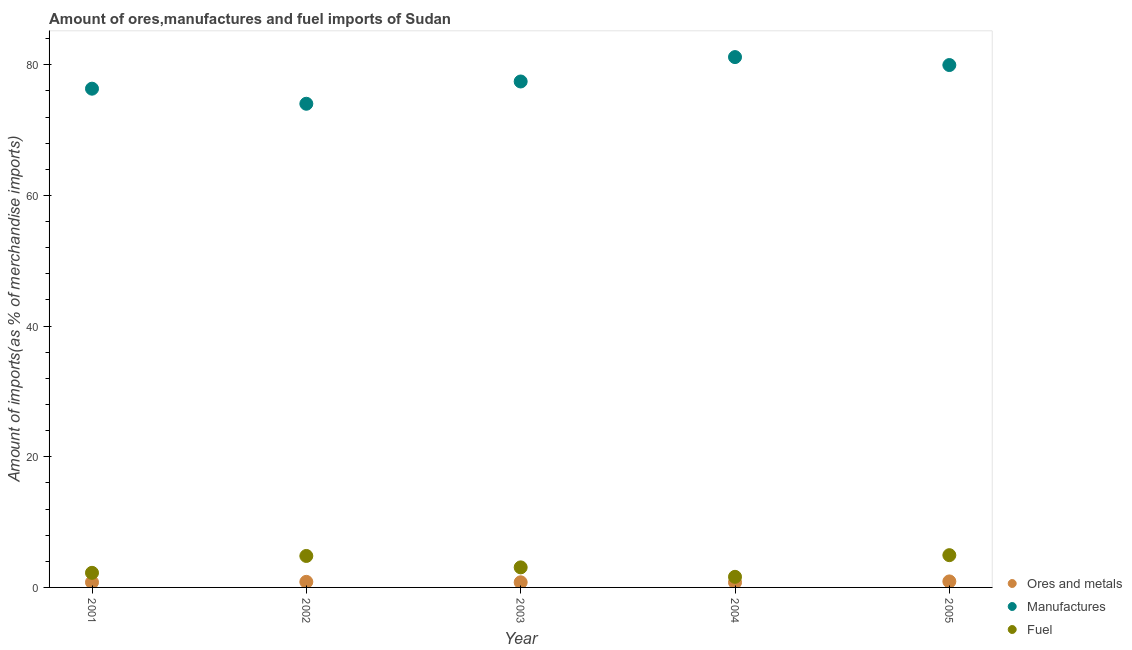What is the percentage of fuel imports in 2003?
Ensure brevity in your answer.  3.07. Across all years, what is the maximum percentage of ores and metals imports?
Offer a very short reply. 0.92. Across all years, what is the minimum percentage of fuel imports?
Your answer should be very brief. 1.62. In which year was the percentage of manufactures imports maximum?
Provide a short and direct response. 2004. In which year was the percentage of fuel imports minimum?
Your answer should be compact. 2004. What is the total percentage of manufactures imports in the graph?
Make the answer very short. 388.96. What is the difference between the percentage of fuel imports in 2002 and that in 2003?
Keep it short and to the point. 1.75. What is the difference between the percentage of fuel imports in 2002 and the percentage of ores and metals imports in 2005?
Offer a very short reply. 3.9. What is the average percentage of manufactures imports per year?
Provide a succinct answer. 77.79. In the year 2002, what is the difference between the percentage of fuel imports and percentage of ores and metals imports?
Provide a succinct answer. 3.96. In how many years, is the percentage of fuel imports greater than 76 %?
Your answer should be very brief. 0. What is the ratio of the percentage of manufactures imports in 2002 to that in 2005?
Offer a very short reply. 0.93. Is the difference between the percentage of fuel imports in 2002 and 2003 greater than the difference between the percentage of manufactures imports in 2002 and 2003?
Provide a short and direct response. Yes. What is the difference between the highest and the second highest percentage of fuel imports?
Keep it short and to the point. 0.12. What is the difference between the highest and the lowest percentage of fuel imports?
Your answer should be compact. 3.31. Is the sum of the percentage of fuel imports in 2001 and 2005 greater than the maximum percentage of ores and metals imports across all years?
Offer a very short reply. Yes. Is it the case that in every year, the sum of the percentage of ores and metals imports and percentage of manufactures imports is greater than the percentage of fuel imports?
Give a very brief answer. Yes. Is the percentage of manufactures imports strictly greater than the percentage of ores and metals imports over the years?
Offer a terse response. Yes. How many years are there in the graph?
Provide a succinct answer. 5. How many legend labels are there?
Give a very brief answer. 3. How are the legend labels stacked?
Your answer should be compact. Vertical. What is the title of the graph?
Provide a short and direct response. Amount of ores,manufactures and fuel imports of Sudan. Does "Ireland" appear as one of the legend labels in the graph?
Provide a succinct answer. No. What is the label or title of the X-axis?
Your answer should be very brief. Year. What is the label or title of the Y-axis?
Your response must be concise. Amount of imports(as % of merchandise imports). What is the Amount of imports(as % of merchandise imports) of Ores and metals in 2001?
Your answer should be compact. 0.78. What is the Amount of imports(as % of merchandise imports) of Manufactures in 2001?
Offer a terse response. 76.34. What is the Amount of imports(as % of merchandise imports) in Fuel in 2001?
Ensure brevity in your answer.  2.23. What is the Amount of imports(as % of merchandise imports) of Ores and metals in 2002?
Provide a short and direct response. 0.85. What is the Amount of imports(as % of merchandise imports) of Manufactures in 2002?
Your answer should be very brief. 74.03. What is the Amount of imports(as % of merchandise imports) of Fuel in 2002?
Provide a succinct answer. 4.82. What is the Amount of imports(as % of merchandise imports) in Ores and metals in 2003?
Offer a very short reply. 0.78. What is the Amount of imports(as % of merchandise imports) in Manufactures in 2003?
Offer a very short reply. 77.44. What is the Amount of imports(as % of merchandise imports) in Fuel in 2003?
Your answer should be compact. 3.07. What is the Amount of imports(as % of merchandise imports) in Ores and metals in 2004?
Your answer should be compact. 0.77. What is the Amount of imports(as % of merchandise imports) in Manufactures in 2004?
Offer a terse response. 81.18. What is the Amount of imports(as % of merchandise imports) in Fuel in 2004?
Make the answer very short. 1.62. What is the Amount of imports(as % of merchandise imports) in Ores and metals in 2005?
Give a very brief answer. 0.92. What is the Amount of imports(as % of merchandise imports) in Manufactures in 2005?
Make the answer very short. 79.96. What is the Amount of imports(as % of merchandise imports) in Fuel in 2005?
Provide a succinct answer. 4.94. Across all years, what is the maximum Amount of imports(as % of merchandise imports) in Ores and metals?
Give a very brief answer. 0.92. Across all years, what is the maximum Amount of imports(as % of merchandise imports) in Manufactures?
Offer a very short reply. 81.18. Across all years, what is the maximum Amount of imports(as % of merchandise imports) of Fuel?
Keep it short and to the point. 4.94. Across all years, what is the minimum Amount of imports(as % of merchandise imports) in Ores and metals?
Ensure brevity in your answer.  0.77. Across all years, what is the minimum Amount of imports(as % of merchandise imports) of Manufactures?
Offer a terse response. 74.03. Across all years, what is the minimum Amount of imports(as % of merchandise imports) of Fuel?
Make the answer very short. 1.62. What is the total Amount of imports(as % of merchandise imports) in Ores and metals in the graph?
Offer a terse response. 4.11. What is the total Amount of imports(as % of merchandise imports) of Manufactures in the graph?
Provide a short and direct response. 388.96. What is the total Amount of imports(as % of merchandise imports) of Fuel in the graph?
Give a very brief answer. 16.68. What is the difference between the Amount of imports(as % of merchandise imports) of Ores and metals in 2001 and that in 2002?
Ensure brevity in your answer.  -0.07. What is the difference between the Amount of imports(as % of merchandise imports) of Manufactures in 2001 and that in 2002?
Your answer should be compact. 2.31. What is the difference between the Amount of imports(as % of merchandise imports) in Fuel in 2001 and that in 2002?
Offer a very short reply. -2.58. What is the difference between the Amount of imports(as % of merchandise imports) in Ores and metals in 2001 and that in 2003?
Keep it short and to the point. -0. What is the difference between the Amount of imports(as % of merchandise imports) in Manufactures in 2001 and that in 2003?
Provide a short and direct response. -1.1. What is the difference between the Amount of imports(as % of merchandise imports) in Fuel in 2001 and that in 2003?
Your response must be concise. -0.83. What is the difference between the Amount of imports(as % of merchandise imports) in Ores and metals in 2001 and that in 2004?
Ensure brevity in your answer.  0.02. What is the difference between the Amount of imports(as % of merchandise imports) in Manufactures in 2001 and that in 2004?
Offer a very short reply. -4.84. What is the difference between the Amount of imports(as % of merchandise imports) of Fuel in 2001 and that in 2004?
Give a very brief answer. 0.61. What is the difference between the Amount of imports(as % of merchandise imports) in Ores and metals in 2001 and that in 2005?
Your response must be concise. -0.14. What is the difference between the Amount of imports(as % of merchandise imports) of Manufactures in 2001 and that in 2005?
Offer a terse response. -3.62. What is the difference between the Amount of imports(as % of merchandise imports) of Fuel in 2001 and that in 2005?
Offer a terse response. -2.7. What is the difference between the Amount of imports(as % of merchandise imports) of Ores and metals in 2002 and that in 2003?
Make the answer very short. 0.07. What is the difference between the Amount of imports(as % of merchandise imports) in Manufactures in 2002 and that in 2003?
Offer a very short reply. -3.41. What is the difference between the Amount of imports(as % of merchandise imports) of Fuel in 2002 and that in 2003?
Make the answer very short. 1.75. What is the difference between the Amount of imports(as % of merchandise imports) in Ores and metals in 2002 and that in 2004?
Offer a terse response. 0.09. What is the difference between the Amount of imports(as % of merchandise imports) of Manufactures in 2002 and that in 2004?
Give a very brief answer. -7.14. What is the difference between the Amount of imports(as % of merchandise imports) of Fuel in 2002 and that in 2004?
Provide a succinct answer. 3.19. What is the difference between the Amount of imports(as % of merchandise imports) of Ores and metals in 2002 and that in 2005?
Give a very brief answer. -0.07. What is the difference between the Amount of imports(as % of merchandise imports) in Manufactures in 2002 and that in 2005?
Offer a terse response. -5.93. What is the difference between the Amount of imports(as % of merchandise imports) of Fuel in 2002 and that in 2005?
Keep it short and to the point. -0.12. What is the difference between the Amount of imports(as % of merchandise imports) in Ores and metals in 2003 and that in 2004?
Your answer should be very brief. 0.02. What is the difference between the Amount of imports(as % of merchandise imports) in Manufactures in 2003 and that in 2004?
Your answer should be very brief. -3.73. What is the difference between the Amount of imports(as % of merchandise imports) in Fuel in 2003 and that in 2004?
Your answer should be very brief. 1.45. What is the difference between the Amount of imports(as % of merchandise imports) in Ores and metals in 2003 and that in 2005?
Your response must be concise. -0.13. What is the difference between the Amount of imports(as % of merchandise imports) of Manufactures in 2003 and that in 2005?
Keep it short and to the point. -2.52. What is the difference between the Amount of imports(as % of merchandise imports) of Fuel in 2003 and that in 2005?
Make the answer very short. -1.87. What is the difference between the Amount of imports(as % of merchandise imports) in Ores and metals in 2004 and that in 2005?
Offer a very short reply. -0.15. What is the difference between the Amount of imports(as % of merchandise imports) of Manufactures in 2004 and that in 2005?
Your answer should be very brief. 1.22. What is the difference between the Amount of imports(as % of merchandise imports) of Fuel in 2004 and that in 2005?
Give a very brief answer. -3.31. What is the difference between the Amount of imports(as % of merchandise imports) of Ores and metals in 2001 and the Amount of imports(as % of merchandise imports) of Manufactures in 2002?
Your answer should be very brief. -73.25. What is the difference between the Amount of imports(as % of merchandise imports) in Ores and metals in 2001 and the Amount of imports(as % of merchandise imports) in Fuel in 2002?
Ensure brevity in your answer.  -4.03. What is the difference between the Amount of imports(as % of merchandise imports) of Manufactures in 2001 and the Amount of imports(as % of merchandise imports) of Fuel in 2002?
Your response must be concise. 71.52. What is the difference between the Amount of imports(as % of merchandise imports) in Ores and metals in 2001 and the Amount of imports(as % of merchandise imports) in Manufactures in 2003?
Your response must be concise. -76.66. What is the difference between the Amount of imports(as % of merchandise imports) in Ores and metals in 2001 and the Amount of imports(as % of merchandise imports) in Fuel in 2003?
Give a very brief answer. -2.29. What is the difference between the Amount of imports(as % of merchandise imports) of Manufactures in 2001 and the Amount of imports(as % of merchandise imports) of Fuel in 2003?
Your answer should be very brief. 73.27. What is the difference between the Amount of imports(as % of merchandise imports) in Ores and metals in 2001 and the Amount of imports(as % of merchandise imports) in Manufactures in 2004?
Your answer should be very brief. -80.39. What is the difference between the Amount of imports(as % of merchandise imports) in Ores and metals in 2001 and the Amount of imports(as % of merchandise imports) in Fuel in 2004?
Give a very brief answer. -0.84. What is the difference between the Amount of imports(as % of merchandise imports) in Manufactures in 2001 and the Amount of imports(as % of merchandise imports) in Fuel in 2004?
Make the answer very short. 74.72. What is the difference between the Amount of imports(as % of merchandise imports) in Ores and metals in 2001 and the Amount of imports(as % of merchandise imports) in Manufactures in 2005?
Give a very brief answer. -79.18. What is the difference between the Amount of imports(as % of merchandise imports) in Ores and metals in 2001 and the Amount of imports(as % of merchandise imports) in Fuel in 2005?
Your answer should be compact. -4.15. What is the difference between the Amount of imports(as % of merchandise imports) in Manufactures in 2001 and the Amount of imports(as % of merchandise imports) in Fuel in 2005?
Offer a very short reply. 71.4. What is the difference between the Amount of imports(as % of merchandise imports) in Ores and metals in 2002 and the Amount of imports(as % of merchandise imports) in Manufactures in 2003?
Your answer should be compact. -76.59. What is the difference between the Amount of imports(as % of merchandise imports) of Ores and metals in 2002 and the Amount of imports(as % of merchandise imports) of Fuel in 2003?
Make the answer very short. -2.22. What is the difference between the Amount of imports(as % of merchandise imports) of Manufactures in 2002 and the Amount of imports(as % of merchandise imports) of Fuel in 2003?
Provide a succinct answer. 70.96. What is the difference between the Amount of imports(as % of merchandise imports) in Ores and metals in 2002 and the Amount of imports(as % of merchandise imports) in Manufactures in 2004?
Provide a succinct answer. -80.33. What is the difference between the Amount of imports(as % of merchandise imports) in Ores and metals in 2002 and the Amount of imports(as % of merchandise imports) in Fuel in 2004?
Ensure brevity in your answer.  -0.77. What is the difference between the Amount of imports(as % of merchandise imports) in Manufactures in 2002 and the Amount of imports(as % of merchandise imports) in Fuel in 2004?
Make the answer very short. 72.41. What is the difference between the Amount of imports(as % of merchandise imports) of Ores and metals in 2002 and the Amount of imports(as % of merchandise imports) of Manufactures in 2005?
Your response must be concise. -79.11. What is the difference between the Amount of imports(as % of merchandise imports) in Ores and metals in 2002 and the Amount of imports(as % of merchandise imports) in Fuel in 2005?
Keep it short and to the point. -4.09. What is the difference between the Amount of imports(as % of merchandise imports) of Manufactures in 2002 and the Amount of imports(as % of merchandise imports) of Fuel in 2005?
Keep it short and to the point. 69.1. What is the difference between the Amount of imports(as % of merchandise imports) in Ores and metals in 2003 and the Amount of imports(as % of merchandise imports) in Manufactures in 2004?
Your answer should be compact. -80.39. What is the difference between the Amount of imports(as % of merchandise imports) of Ores and metals in 2003 and the Amount of imports(as % of merchandise imports) of Fuel in 2004?
Provide a succinct answer. -0.84. What is the difference between the Amount of imports(as % of merchandise imports) of Manufactures in 2003 and the Amount of imports(as % of merchandise imports) of Fuel in 2004?
Offer a terse response. 75.82. What is the difference between the Amount of imports(as % of merchandise imports) in Ores and metals in 2003 and the Amount of imports(as % of merchandise imports) in Manufactures in 2005?
Provide a succinct answer. -79.18. What is the difference between the Amount of imports(as % of merchandise imports) of Ores and metals in 2003 and the Amount of imports(as % of merchandise imports) of Fuel in 2005?
Provide a short and direct response. -4.15. What is the difference between the Amount of imports(as % of merchandise imports) of Manufactures in 2003 and the Amount of imports(as % of merchandise imports) of Fuel in 2005?
Your answer should be compact. 72.51. What is the difference between the Amount of imports(as % of merchandise imports) in Ores and metals in 2004 and the Amount of imports(as % of merchandise imports) in Manufactures in 2005?
Your answer should be very brief. -79.19. What is the difference between the Amount of imports(as % of merchandise imports) in Ores and metals in 2004 and the Amount of imports(as % of merchandise imports) in Fuel in 2005?
Keep it short and to the point. -4.17. What is the difference between the Amount of imports(as % of merchandise imports) in Manufactures in 2004 and the Amount of imports(as % of merchandise imports) in Fuel in 2005?
Give a very brief answer. 76.24. What is the average Amount of imports(as % of merchandise imports) of Ores and metals per year?
Ensure brevity in your answer.  0.82. What is the average Amount of imports(as % of merchandise imports) of Manufactures per year?
Your response must be concise. 77.79. What is the average Amount of imports(as % of merchandise imports) of Fuel per year?
Give a very brief answer. 3.34. In the year 2001, what is the difference between the Amount of imports(as % of merchandise imports) in Ores and metals and Amount of imports(as % of merchandise imports) in Manufactures?
Your response must be concise. -75.56. In the year 2001, what is the difference between the Amount of imports(as % of merchandise imports) of Ores and metals and Amount of imports(as % of merchandise imports) of Fuel?
Ensure brevity in your answer.  -1.45. In the year 2001, what is the difference between the Amount of imports(as % of merchandise imports) of Manufactures and Amount of imports(as % of merchandise imports) of Fuel?
Offer a terse response. 74.11. In the year 2002, what is the difference between the Amount of imports(as % of merchandise imports) of Ores and metals and Amount of imports(as % of merchandise imports) of Manufactures?
Offer a very short reply. -73.18. In the year 2002, what is the difference between the Amount of imports(as % of merchandise imports) in Ores and metals and Amount of imports(as % of merchandise imports) in Fuel?
Provide a succinct answer. -3.96. In the year 2002, what is the difference between the Amount of imports(as % of merchandise imports) in Manufactures and Amount of imports(as % of merchandise imports) in Fuel?
Make the answer very short. 69.22. In the year 2003, what is the difference between the Amount of imports(as % of merchandise imports) of Ores and metals and Amount of imports(as % of merchandise imports) of Manufactures?
Give a very brief answer. -76.66. In the year 2003, what is the difference between the Amount of imports(as % of merchandise imports) in Ores and metals and Amount of imports(as % of merchandise imports) in Fuel?
Give a very brief answer. -2.28. In the year 2003, what is the difference between the Amount of imports(as % of merchandise imports) of Manufactures and Amount of imports(as % of merchandise imports) of Fuel?
Offer a very short reply. 74.37. In the year 2004, what is the difference between the Amount of imports(as % of merchandise imports) of Ores and metals and Amount of imports(as % of merchandise imports) of Manufactures?
Your response must be concise. -80.41. In the year 2004, what is the difference between the Amount of imports(as % of merchandise imports) of Ores and metals and Amount of imports(as % of merchandise imports) of Fuel?
Ensure brevity in your answer.  -0.86. In the year 2004, what is the difference between the Amount of imports(as % of merchandise imports) of Manufactures and Amount of imports(as % of merchandise imports) of Fuel?
Make the answer very short. 79.55. In the year 2005, what is the difference between the Amount of imports(as % of merchandise imports) in Ores and metals and Amount of imports(as % of merchandise imports) in Manufactures?
Make the answer very short. -79.04. In the year 2005, what is the difference between the Amount of imports(as % of merchandise imports) in Ores and metals and Amount of imports(as % of merchandise imports) in Fuel?
Offer a very short reply. -4.02. In the year 2005, what is the difference between the Amount of imports(as % of merchandise imports) of Manufactures and Amount of imports(as % of merchandise imports) of Fuel?
Your answer should be very brief. 75.02. What is the ratio of the Amount of imports(as % of merchandise imports) in Ores and metals in 2001 to that in 2002?
Your response must be concise. 0.92. What is the ratio of the Amount of imports(as % of merchandise imports) in Manufactures in 2001 to that in 2002?
Provide a short and direct response. 1.03. What is the ratio of the Amount of imports(as % of merchandise imports) in Fuel in 2001 to that in 2002?
Give a very brief answer. 0.46. What is the ratio of the Amount of imports(as % of merchandise imports) of Manufactures in 2001 to that in 2003?
Offer a terse response. 0.99. What is the ratio of the Amount of imports(as % of merchandise imports) of Fuel in 2001 to that in 2003?
Your answer should be compact. 0.73. What is the ratio of the Amount of imports(as % of merchandise imports) in Ores and metals in 2001 to that in 2004?
Provide a succinct answer. 1.02. What is the ratio of the Amount of imports(as % of merchandise imports) of Manufactures in 2001 to that in 2004?
Offer a terse response. 0.94. What is the ratio of the Amount of imports(as % of merchandise imports) in Fuel in 2001 to that in 2004?
Give a very brief answer. 1.38. What is the ratio of the Amount of imports(as % of merchandise imports) of Ores and metals in 2001 to that in 2005?
Your answer should be compact. 0.85. What is the ratio of the Amount of imports(as % of merchandise imports) in Manufactures in 2001 to that in 2005?
Ensure brevity in your answer.  0.95. What is the ratio of the Amount of imports(as % of merchandise imports) in Fuel in 2001 to that in 2005?
Your answer should be very brief. 0.45. What is the ratio of the Amount of imports(as % of merchandise imports) of Ores and metals in 2002 to that in 2003?
Offer a terse response. 1.09. What is the ratio of the Amount of imports(as % of merchandise imports) in Manufactures in 2002 to that in 2003?
Your answer should be very brief. 0.96. What is the ratio of the Amount of imports(as % of merchandise imports) in Fuel in 2002 to that in 2003?
Keep it short and to the point. 1.57. What is the ratio of the Amount of imports(as % of merchandise imports) in Manufactures in 2002 to that in 2004?
Your answer should be very brief. 0.91. What is the ratio of the Amount of imports(as % of merchandise imports) in Fuel in 2002 to that in 2004?
Make the answer very short. 2.97. What is the ratio of the Amount of imports(as % of merchandise imports) in Ores and metals in 2002 to that in 2005?
Your answer should be compact. 0.93. What is the ratio of the Amount of imports(as % of merchandise imports) of Manufactures in 2002 to that in 2005?
Your response must be concise. 0.93. What is the ratio of the Amount of imports(as % of merchandise imports) of Fuel in 2002 to that in 2005?
Give a very brief answer. 0.98. What is the ratio of the Amount of imports(as % of merchandise imports) in Ores and metals in 2003 to that in 2004?
Make the answer very short. 1.02. What is the ratio of the Amount of imports(as % of merchandise imports) of Manufactures in 2003 to that in 2004?
Give a very brief answer. 0.95. What is the ratio of the Amount of imports(as % of merchandise imports) in Fuel in 2003 to that in 2004?
Keep it short and to the point. 1.89. What is the ratio of the Amount of imports(as % of merchandise imports) in Ores and metals in 2003 to that in 2005?
Your answer should be very brief. 0.85. What is the ratio of the Amount of imports(as % of merchandise imports) of Manufactures in 2003 to that in 2005?
Make the answer very short. 0.97. What is the ratio of the Amount of imports(as % of merchandise imports) of Fuel in 2003 to that in 2005?
Give a very brief answer. 0.62. What is the ratio of the Amount of imports(as % of merchandise imports) in Ores and metals in 2004 to that in 2005?
Your response must be concise. 0.83. What is the ratio of the Amount of imports(as % of merchandise imports) in Manufactures in 2004 to that in 2005?
Provide a short and direct response. 1.02. What is the ratio of the Amount of imports(as % of merchandise imports) in Fuel in 2004 to that in 2005?
Keep it short and to the point. 0.33. What is the difference between the highest and the second highest Amount of imports(as % of merchandise imports) in Ores and metals?
Your answer should be very brief. 0.07. What is the difference between the highest and the second highest Amount of imports(as % of merchandise imports) in Manufactures?
Provide a succinct answer. 1.22. What is the difference between the highest and the second highest Amount of imports(as % of merchandise imports) in Fuel?
Your answer should be compact. 0.12. What is the difference between the highest and the lowest Amount of imports(as % of merchandise imports) of Ores and metals?
Make the answer very short. 0.15. What is the difference between the highest and the lowest Amount of imports(as % of merchandise imports) in Manufactures?
Keep it short and to the point. 7.14. What is the difference between the highest and the lowest Amount of imports(as % of merchandise imports) in Fuel?
Provide a short and direct response. 3.31. 